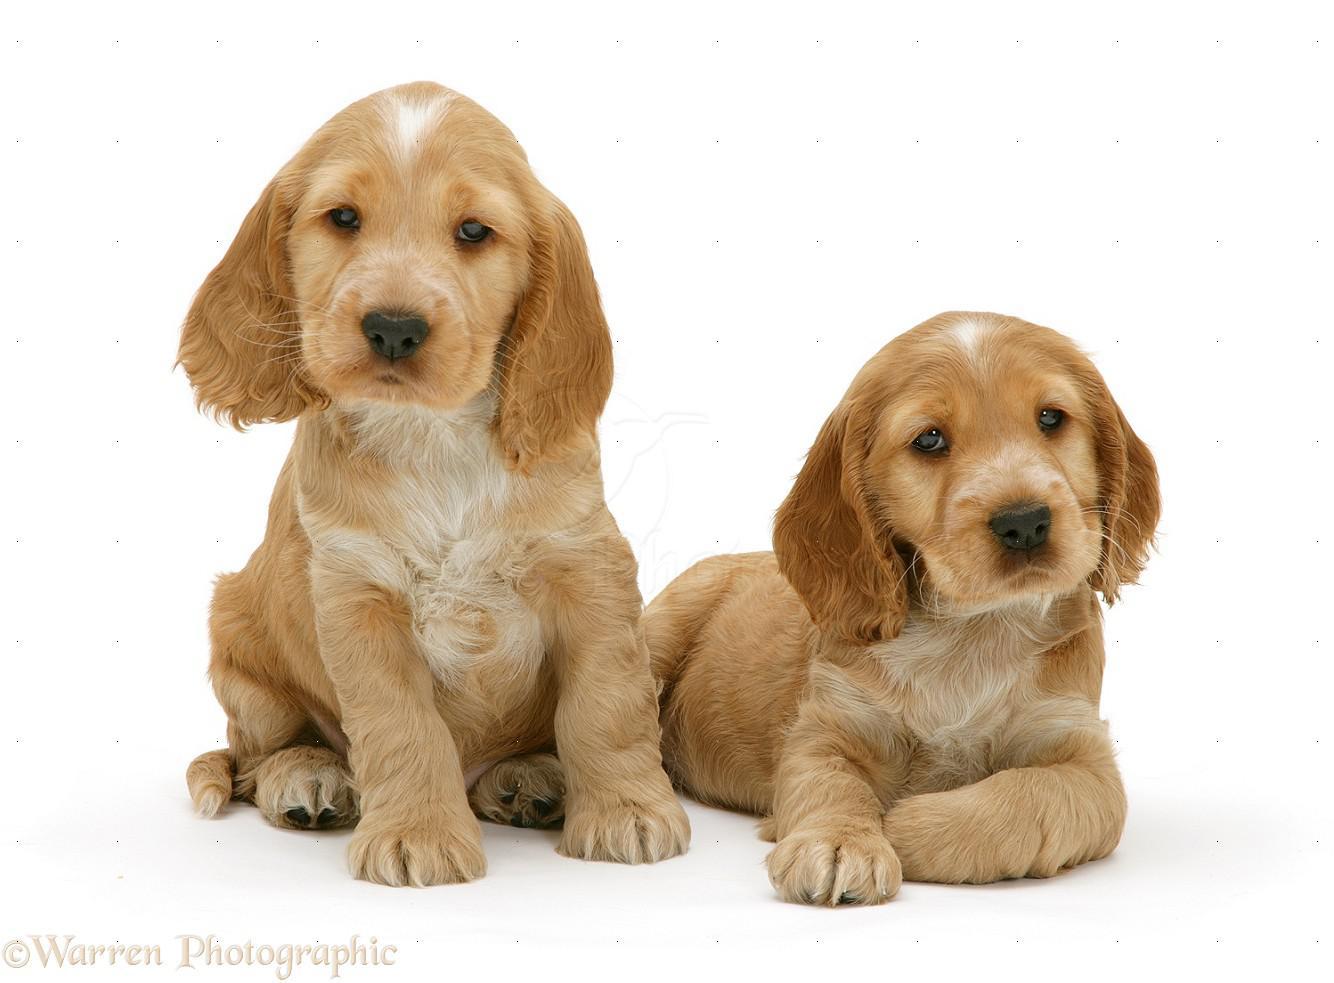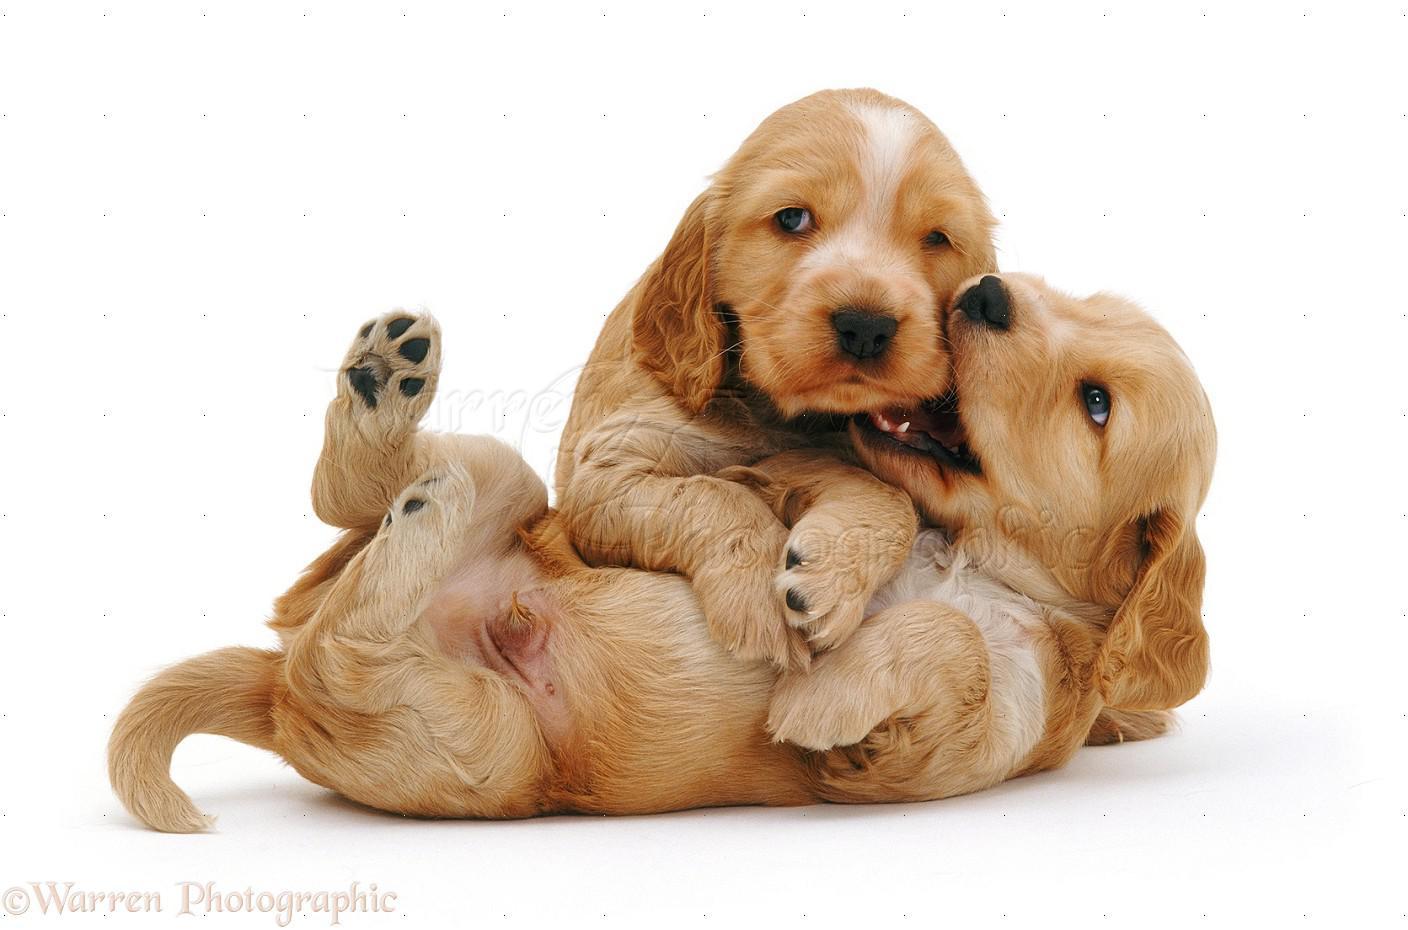The first image is the image on the left, the second image is the image on the right. For the images shown, is this caption "There's at least two dogs in the right image." true? Answer yes or no. Yes. The first image is the image on the left, the second image is the image on the right. Considering the images on both sides, is "One image shows a golden-haired puppy posing with an animal that is not a puppy." valid? Answer yes or no. No. 